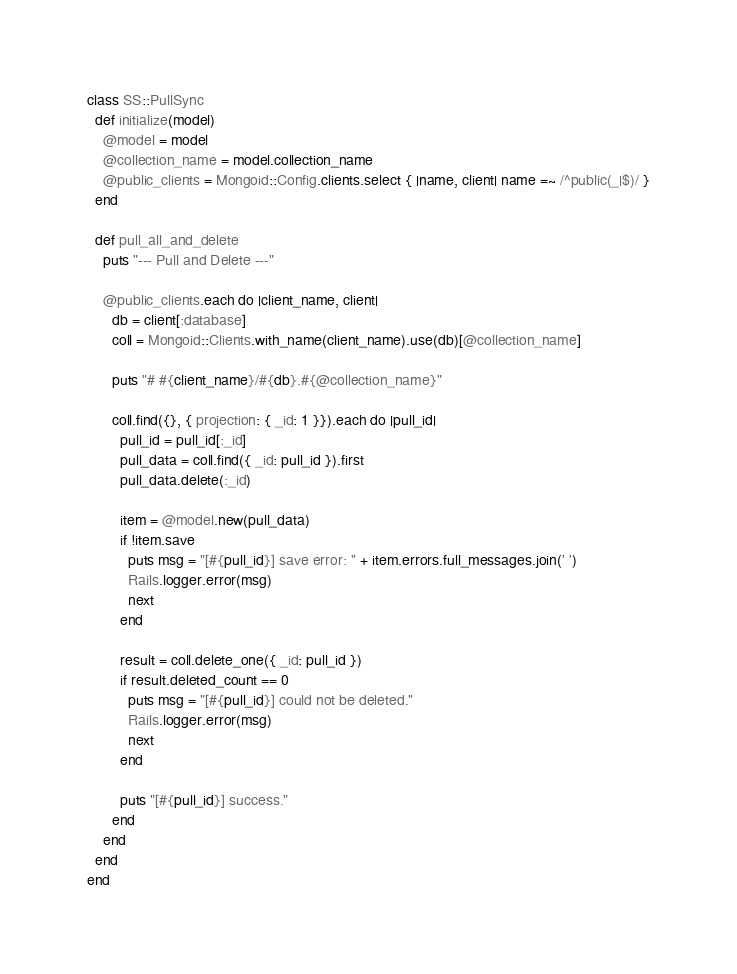<code> <loc_0><loc_0><loc_500><loc_500><_Ruby_>class SS::PullSync
  def initialize(model)
    @model = model
    @collection_name = model.collection_name
    @public_clients = Mongoid::Config.clients.select { |name, client| name =~ /^public(_|$)/ }
  end

  def pull_all_and_delete
    puts "--- Pull and Delete ---"

    @public_clients.each do |client_name, client|
      db = client[:database]
      coll = Mongoid::Clients.with_name(client_name).use(db)[@collection_name]

      puts "# #{client_name}/#{db}.#{@collection_name}"

      coll.find({}, { projection: { _id: 1 }}).each do |pull_id|
        pull_id = pull_id[:_id]
        pull_data = coll.find({ _id: pull_id }).first
        pull_data.delete(:_id)

        item = @model.new(pull_data)
        if !item.save
          puts msg = "[#{pull_id}] save error: " + item.errors.full_messages.join(' ')
          Rails.logger.error(msg)
          next
        end

        result = coll.delete_one({ _id: pull_id })
        if result.deleted_count == 0
          puts msg = "[#{pull_id}] could not be deleted."
          Rails.logger.error(msg)
          next
        end

        puts "[#{pull_id}] success."
      end
    end
  end
end
</code> 